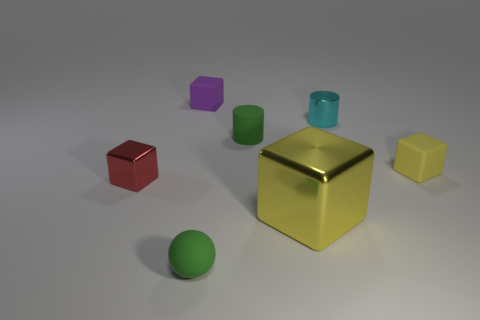Subtract all brown blocks. Subtract all yellow cylinders. How many blocks are left? 4 Add 3 tiny green cylinders. How many objects exist? 10 Subtract all spheres. How many objects are left? 6 Add 2 yellow blocks. How many yellow blocks exist? 4 Subtract 0 gray spheres. How many objects are left? 7 Subtract all small cyan metal cylinders. Subtract all spheres. How many objects are left? 5 Add 3 small green matte objects. How many small green matte objects are left? 5 